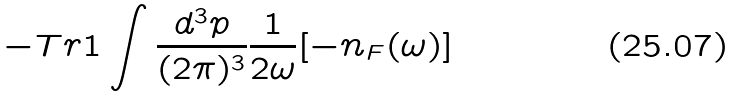Convert formula to latex. <formula><loc_0><loc_0><loc_500><loc_500>- T r { 1 } \int \frac { d ^ { 3 } p } { ( 2 \pi ) ^ { 3 } } \frac { 1 } { 2 \omega } [ - n _ { F } ( \omega ) ]</formula> 